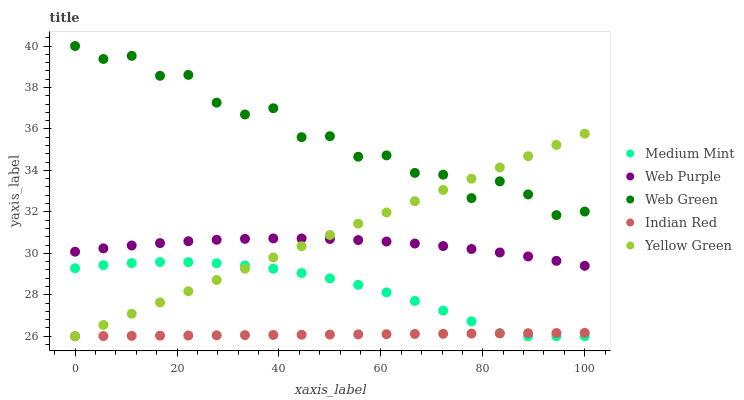Does Indian Red have the minimum area under the curve?
Answer yes or no. Yes. Does Web Green have the maximum area under the curve?
Answer yes or no. Yes. Does Web Purple have the minimum area under the curve?
Answer yes or no. No. Does Web Purple have the maximum area under the curve?
Answer yes or no. No. Is Indian Red the smoothest?
Answer yes or no. Yes. Is Web Green the roughest?
Answer yes or no. Yes. Is Web Purple the smoothest?
Answer yes or no. No. Is Web Purple the roughest?
Answer yes or no. No. Does Medium Mint have the lowest value?
Answer yes or no. Yes. Does Web Purple have the lowest value?
Answer yes or no. No. Does Web Green have the highest value?
Answer yes or no. Yes. Does Web Purple have the highest value?
Answer yes or no. No. Is Web Purple less than Web Green?
Answer yes or no. Yes. Is Web Purple greater than Indian Red?
Answer yes or no. Yes. Does Web Purple intersect Yellow Green?
Answer yes or no. Yes. Is Web Purple less than Yellow Green?
Answer yes or no. No. Is Web Purple greater than Yellow Green?
Answer yes or no. No. Does Web Purple intersect Web Green?
Answer yes or no. No. 